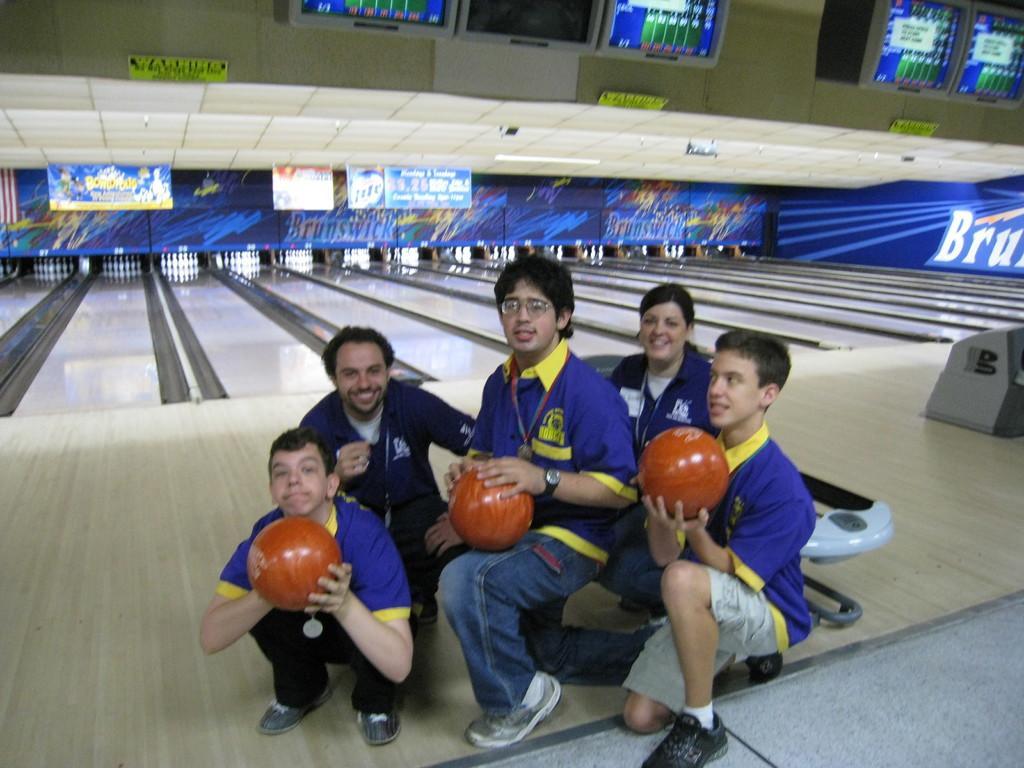Could you give a brief overview of what you see in this image? In the center of the image, we can see people bending on their knees and some of them are holding balls in their hands. In the background, we can see a building and at the bottom, there is a floor. 